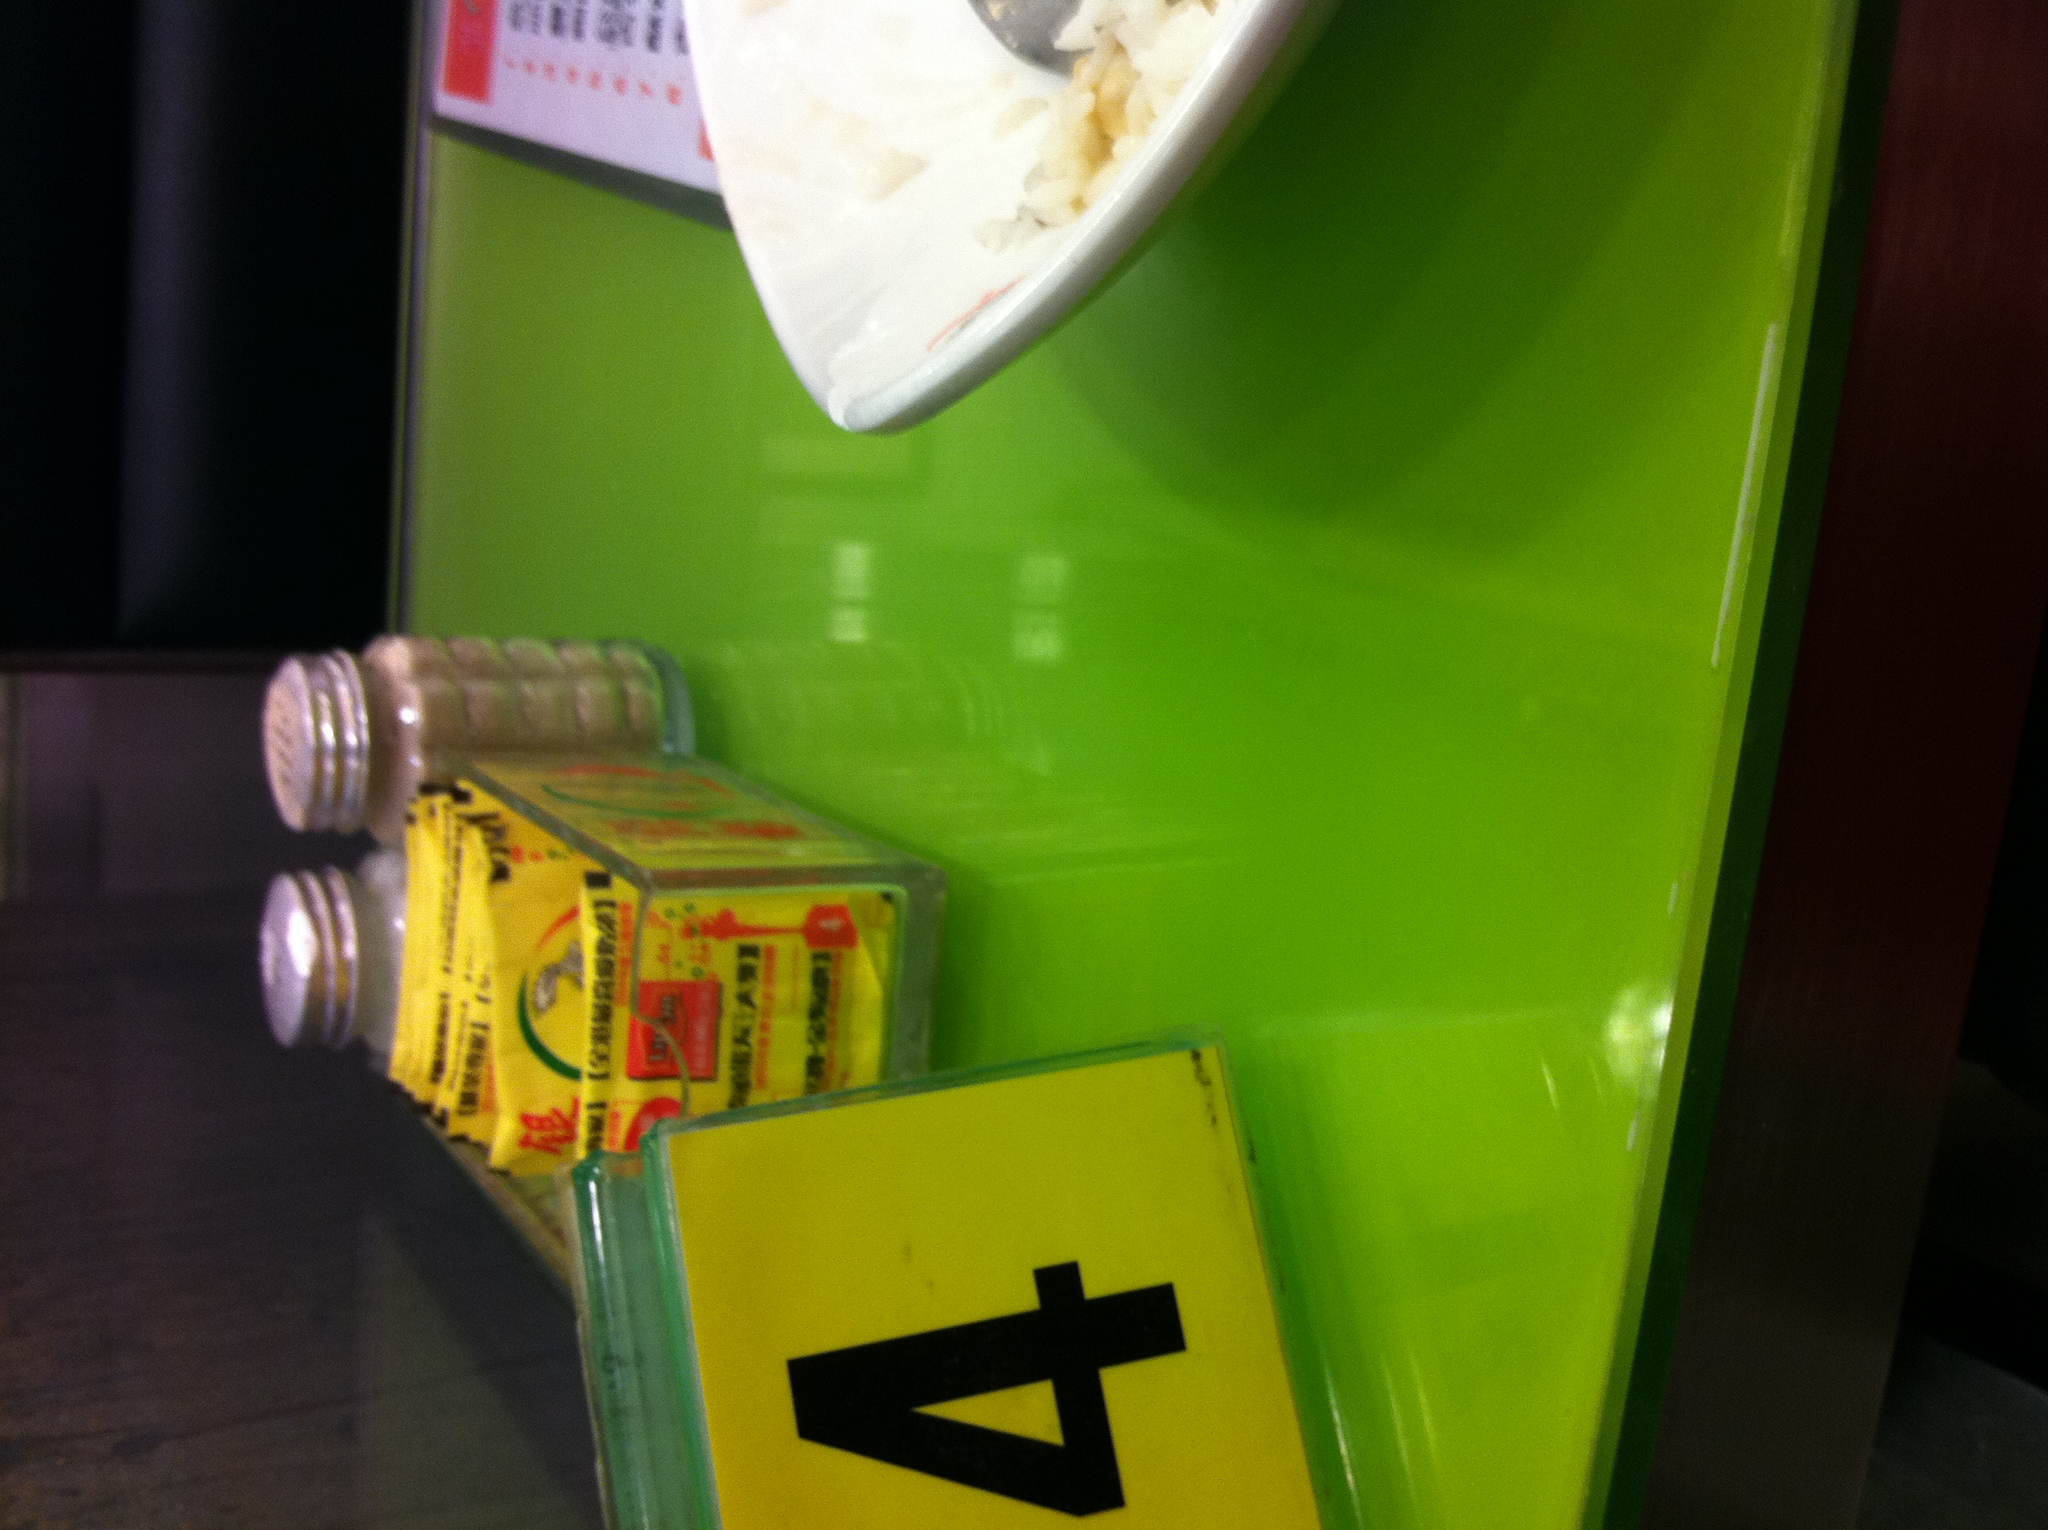Describe the scene in detail. The image shows a close-up view of a table with a bright green surface. On the table, there's a yellow table number sign with the number 4 prominently displayed. Beside it, there is a bowl containing what appears to be white rice with a spoon placed in it. Next to the bowl, there are two shakers that likely contain salt and pepper, and in front of them, there is a small carton box that seems to be for some kind of food seasoning or condiment. The overall scene suggests a casual dining setup. 